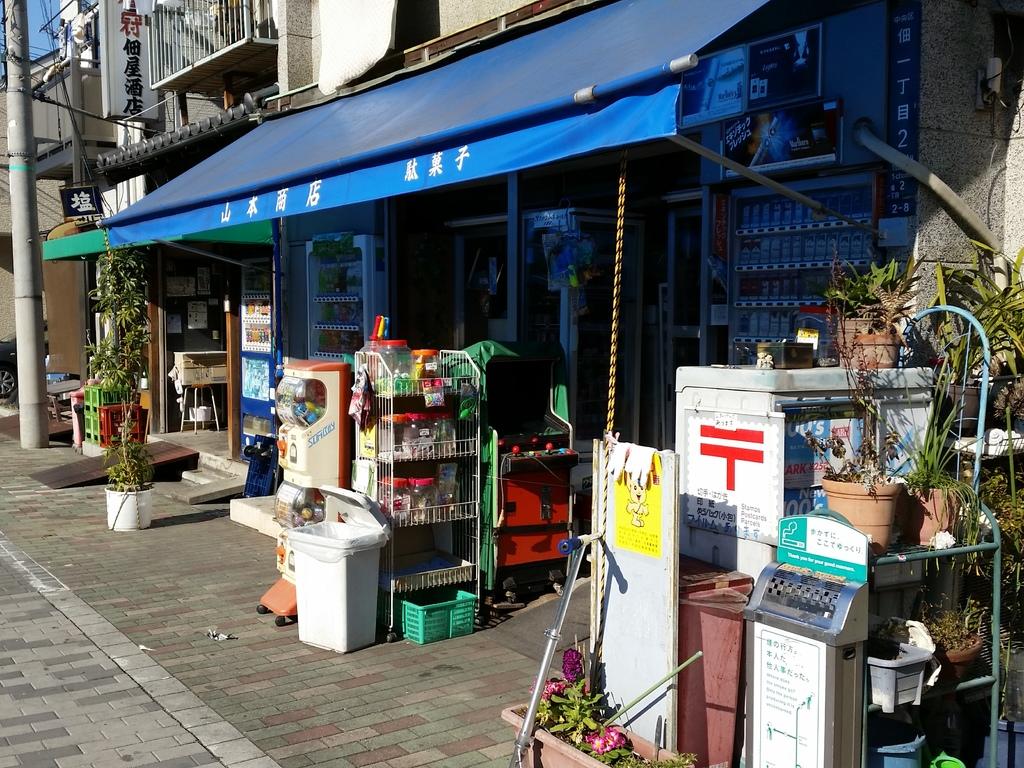Is this chinese?
Your answer should be very brief. Yes. 